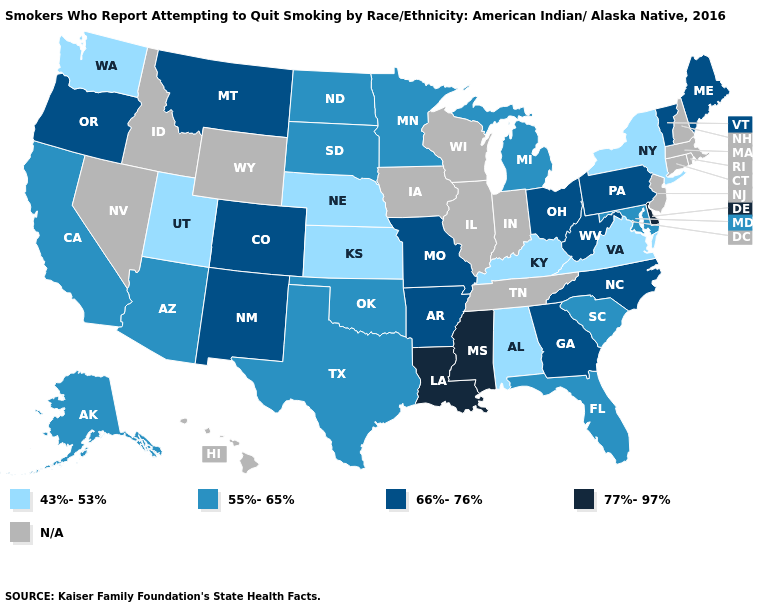Name the states that have a value in the range 66%-76%?
Concise answer only. Arkansas, Colorado, Georgia, Maine, Missouri, Montana, New Mexico, North Carolina, Ohio, Oregon, Pennsylvania, Vermont, West Virginia. Which states have the lowest value in the USA?
Keep it brief. Alabama, Kansas, Kentucky, Nebraska, New York, Utah, Virginia, Washington. Name the states that have a value in the range N/A?
Write a very short answer. Connecticut, Hawaii, Idaho, Illinois, Indiana, Iowa, Massachusetts, Nevada, New Hampshire, New Jersey, Rhode Island, Tennessee, Wisconsin, Wyoming. What is the value of Florida?
Write a very short answer. 55%-65%. Which states have the lowest value in the MidWest?
Write a very short answer. Kansas, Nebraska. Among the states that border Oregon , which have the lowest value?
Answer briefly. Washington. What is the highest value in the Northeast ?
Write a very short answer. 66%-76%. Does New York have the lowest value in the USA?
Write a very short answer. Yes. What is the value of Alabama?
Write a very short answer. 43%-53%. Name the states that have a value in the range 43%-53%?
Answer briefly. Alabama, Kansas, Kentucky, Nebraska, New York, Utah, Virginia, Washington. Does Arizona have the lowest value in the West?
Write a very short answer. No. Name the states that have a value in the range 66%-76%?
Keep it brief. Arkansas, Colorado, Georgia, Maine, Missouri, Montana, New Mexico, North Carolina, Ohio, Oregon, Pennsylvania, Vermont, West Virginia. Among the states that border Maryland , does Delaware have the highest value?
Answer briefly. Yes. Does California have the lowest value in the USA?
Keep it brief. No. 